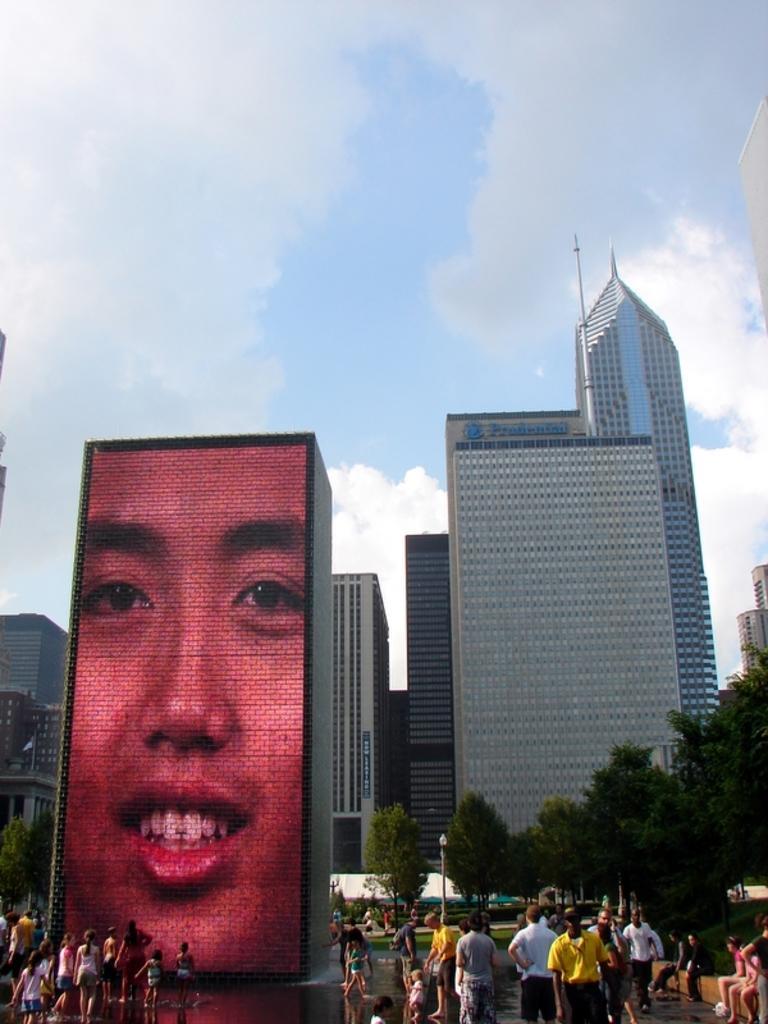Describe this image in one or two sentences. In this image I can see group of people standing. In front I can see a screen, in the screen I can see a person face, background I can see few buildings in white color and sky is in blue and white color. 